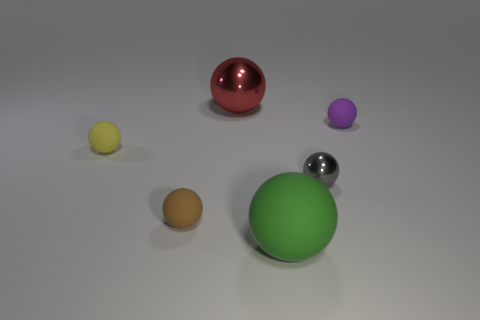The large thing that is behind the matte thing to the right of the green matte sphere is made of what material?
Provide a succinct answer. Metal. Are there more tiny spheres in front of the gray object than large matte cylinders?
Provide a short and direct response. Yes. Is there another purple thing that has the same material as the small purple thing?
Give a very brief answer. No. There is a small rubber thing on the right side of the red metal sphere; does it have the same shape as the small gray metal thing?
Your answer should be compact. Yes. How many rubber things are to the left of the metal sphere that is in front of the large ball behind the small purple matte ball?
Give a very brief answer. 3. Are there fewer brown rubber things behind the yellow matte thing than red spheres on the right side of the large red sphere?
Your answer should be very brief. No. There is another large object that is the same shape as the large red object; what is its color?
Your response must be concise. Green. What is the size of the brown thing?
Your answer should be very brief. Small. How many red metallic balls have the same size as the green sphere?
Your answer should be compact. 1. Does the large thing that is in front of the small purple sphere have the same material as the small object that is behind the tiny yellow matte sphere?
Give a very brief answer. Yes. 